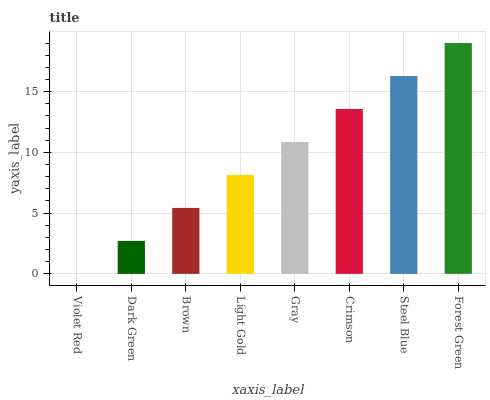Is Violet Red the minimum?
Answer yes or no. Yes. Is Forest Green the maximum?
Answer yes or no. Yes. Is Dark Green the minimum?
Answer yes or no. No. Is Dark Green the maximum?
Answer yes or no. No. Is Dark Green greater than Violet Red?
Answer yes or no. Yes. Is Violet Red less than Dark Green?
Answer yes or no. Yes. Is Violet Red greater than Dark Green?
Answer yes or no. No. Is Dark Green less than Violet Red?
Answer yes or no. No. Is Gray the high median?
Answer yes or no. Yes. Is Light Gold the low median?
Answer yes or no. Yes. Is Steel Blue the high median?
Answer yes or no. No. Is Brown the low median?
Answer yes or no. No. 